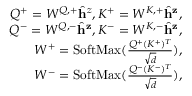Convert formula to latex. <formula><loc_0><loc_0><loc_500><loc_500>\begin{array} { r } { Q ^ { + } = W ^ { Q , + } \hat { h } ^ { z } , K ^ { + } = W ^ { K , + } \hat { h } ^ { z } , } \\ { Q ^ { - } = W ^ { Q , - } \hat { h } ^ { z } , K ^ { - } = W ^ { K , - } \hat { h } ^ { z } , } \\ { W ^ { + } = S o f t M a x ( \frac { Q ^ { + } ( K ^ { + } ) ^ { T } } { \sqrt { d } } ) , } \\ { W ^ { - } = S o f t M a x ( \frac { Q ^ { - } ( K ^ { - } ) ^ { T } } { \sqrt { d } } ) , } \end{array}</formula> 